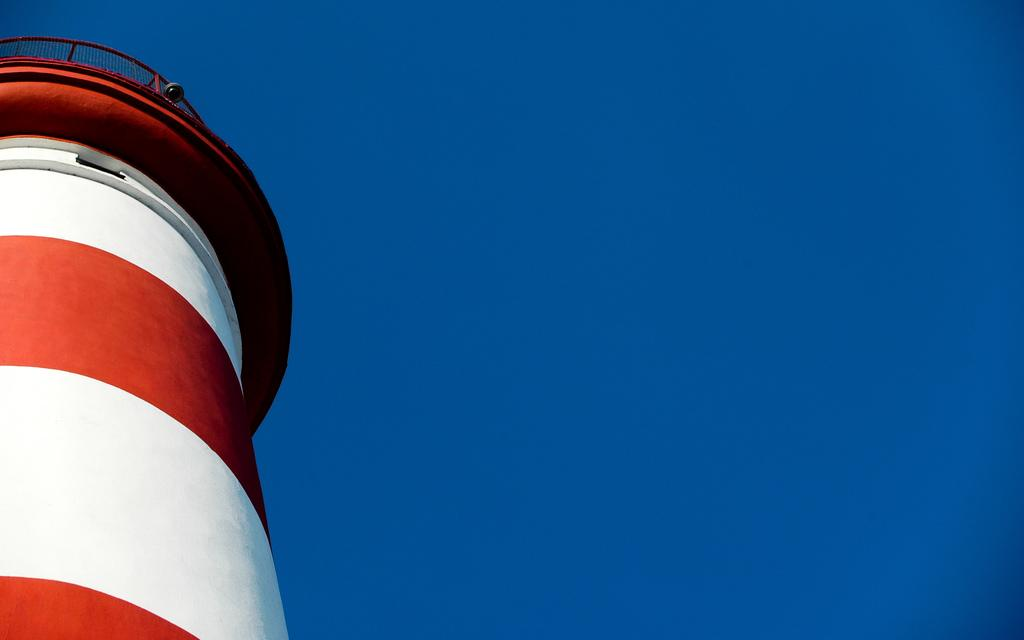What is the main structure in the image? There is a tower in the image. Where is the tower located in the image? The tower is towards the left side of the image. What colors can be seen on the tower? The tower is white and red in color. What else can be seen in the image besides the tower? There is a sky visible in the image. How many horses are present at the party in the image? There are no horses or parties present in the image; it features a tower and a sky. 